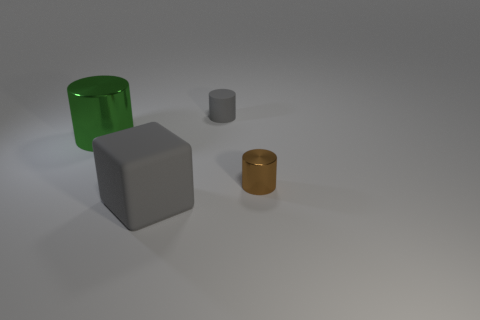Can you describe the lighting in this scene? The scene is softly lit with what appears to be a diffused light source coming from the upper left, casting gentle shadows to the right of the objects. This creates a calm and uniform atmosphere without harsh contrasts. 